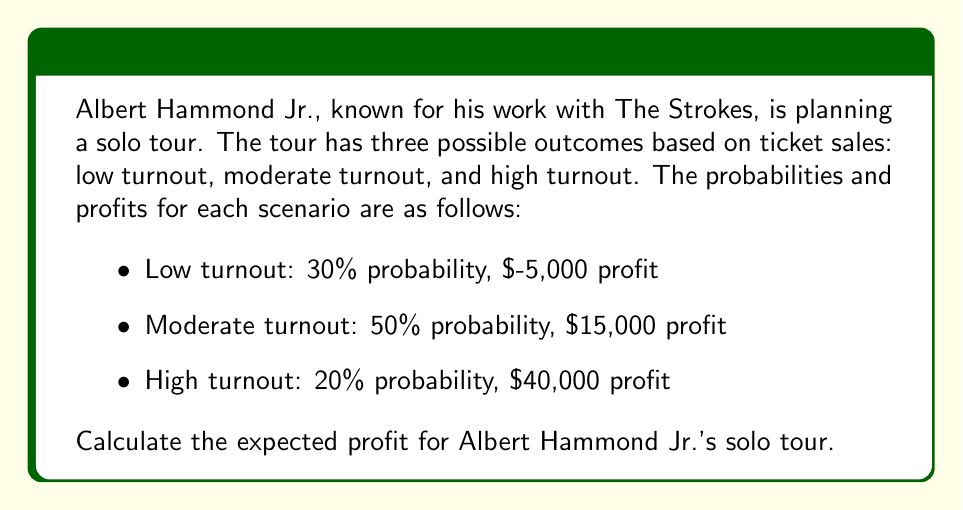Show me your answer to this math problem. To calculate the expected profit, we need to use the concept of expected value. The expected value is the sum of each possible outcome multiplied by its probability.

Let's define our variables:
$P(L)$ = Probability of low turnout = 0.30
$P(M)$ = Probability of moderate turnout = 0.50
$P(H)$ = Probability of high turnout = 0.20

$\pi(L)$ = Profit from low turnout = $-5,000
$\pi(M)$ = Profit from moderate turnout = $15,000
$\pi(H)$ = Profit from high turnout = $40,000

The formula for expected profit $E(\pi)$ is:

$$E(\pi) = P(L) \cdot \pi(L) + P(M) \cdot \pi(M) + P(H) \cdot \pi(H)$$

Now, let's substitute the values:

$$E(\pi) = 0.30 \cdot (-5,000) + 0.50 \cdot 15,000 + 0.20 \cdot 40,000$$

Calculating each term:
1. $0.30 \cdot (-5,000) = -1,500$
2. $0.50 \cdot 15,000 = 7,500$
3. $0.20 \cdot 40,000 = 8,000$

Adding these together:

$$E(\pi) = -1,500 + 7,500 + 8,000 = 14,000$$

Therefore, the expected profit for Albert Hammond Jr.'s solo tour is $14,000.
Answer: $14,000 